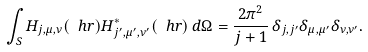<formula> <loc_0><loc_0><loc_500><loc_500>\int _ { S } H _ { j , \mu , \nu } ( \ h r ) H ^ { * } _ { j ^ { \prime } , \mu ^ { \prime } , \nu ^ { \prime } } ( \ h r ) \, d \Omega = \frac { 2 \pi ^ { 2 } } { j + 1 } \, \delta _ { j , j ^ { \prime } } \delta _ { \mu , \mu ^ { \prime } } \delta _ { \nu , \nu ^ { \prime } } .</formula> 